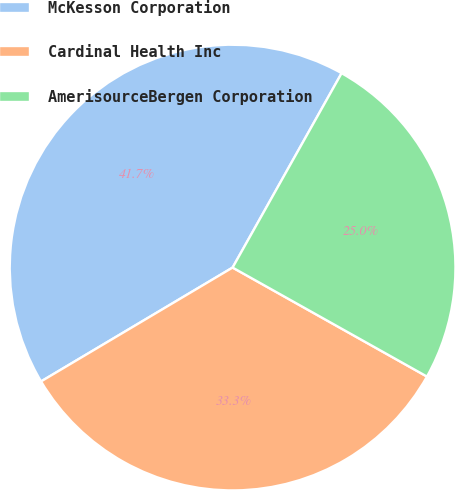Convert chart. <chart><loc_0><loc_0><loc_500><loc_500><pie_chart><fcel>McKesson Corporation<fcel>Cardinal Health Inc<fcel>AmerisourceBergen Corporation<nl><fcel>41.67%<fcel>33.33%<fcel>25.0%<nl></chart> 